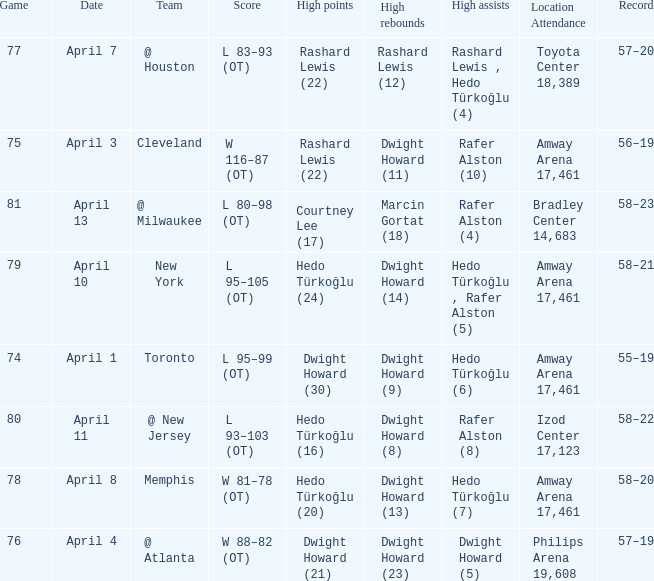Which player had the highest points in game 79? Hedo Türkoğlu (24). 